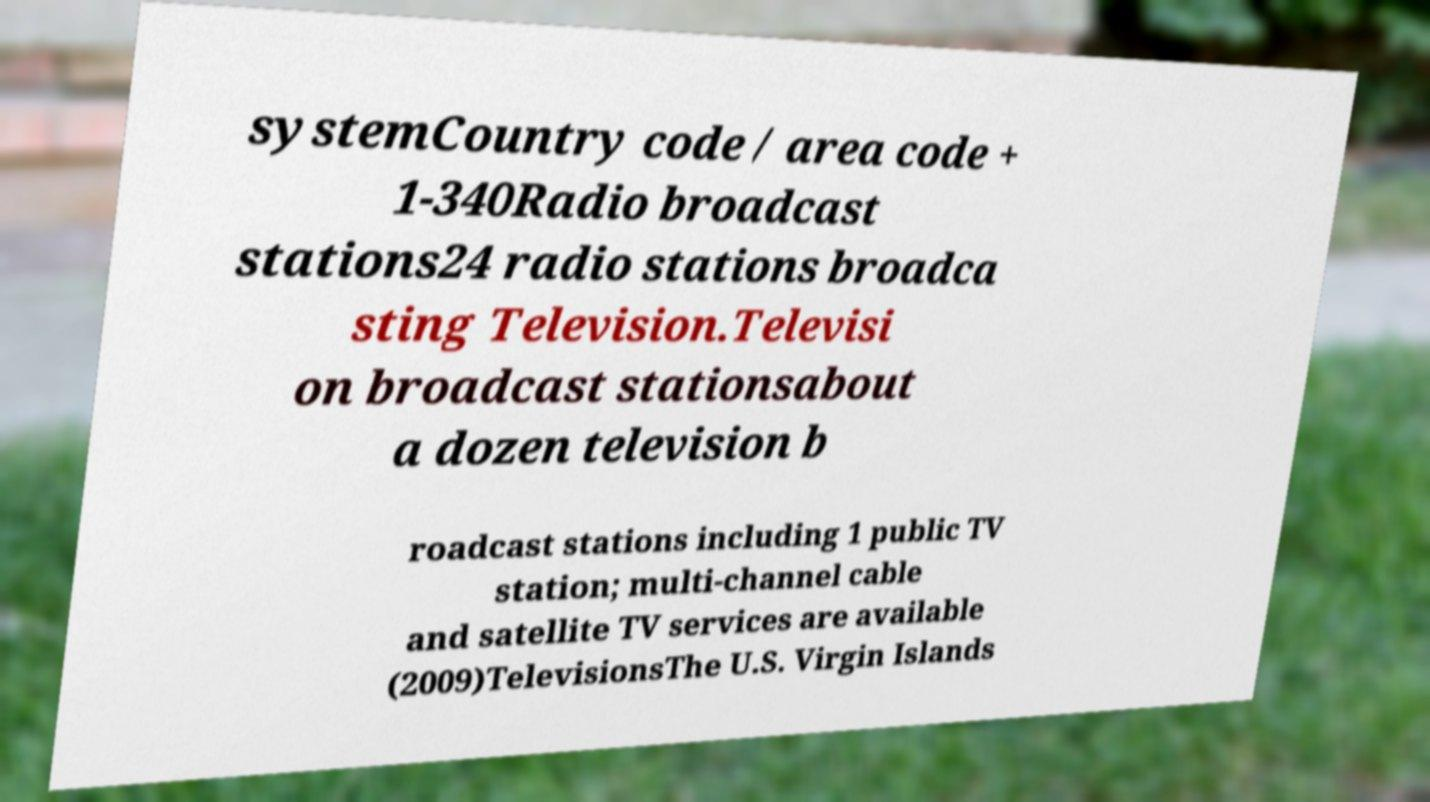Can you read and provide the text displayed in the image?This photo seems to have some interesting text. Can you extract and type it out for me? systemCountry code / area code + 1-340Radio broadcast stations24 radio stations broadca sting Television.Televisi on broadcast stationsabout a dozen television b roadcast stations including 1 public TV station; multi-channel cable and satellite TV services are available (2009)TelevisionsThe U.S. Virgin Islands 